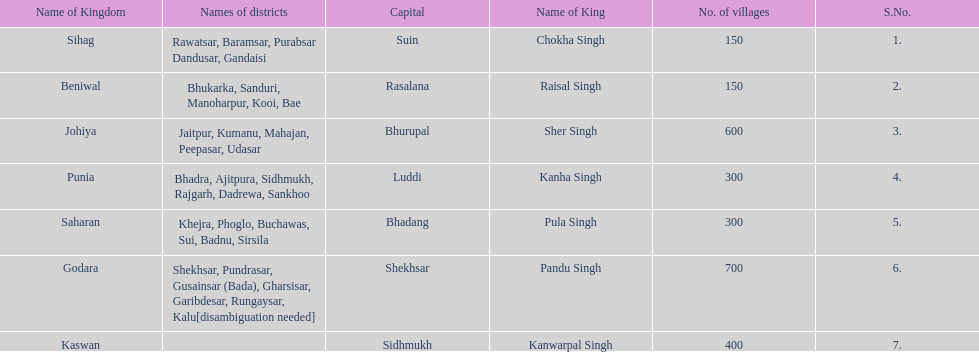What was the total number of districts within the state of godara? 7. 